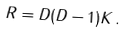Convert formula to latex. <formula><loc_0><loc_0><loc_500><loc_500>R = D ( D - 1 ) K \, .</formula> 